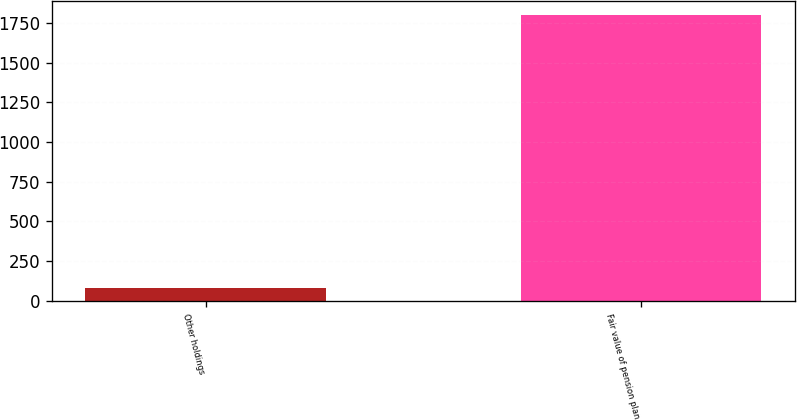<chart> <loc_0><loc_0><loc_500><loc_500><bar_chart><fcel>Other holdings<fcel>Fair value of pension plan<nl><fcel>81<fcel>1800<nl></chart> 